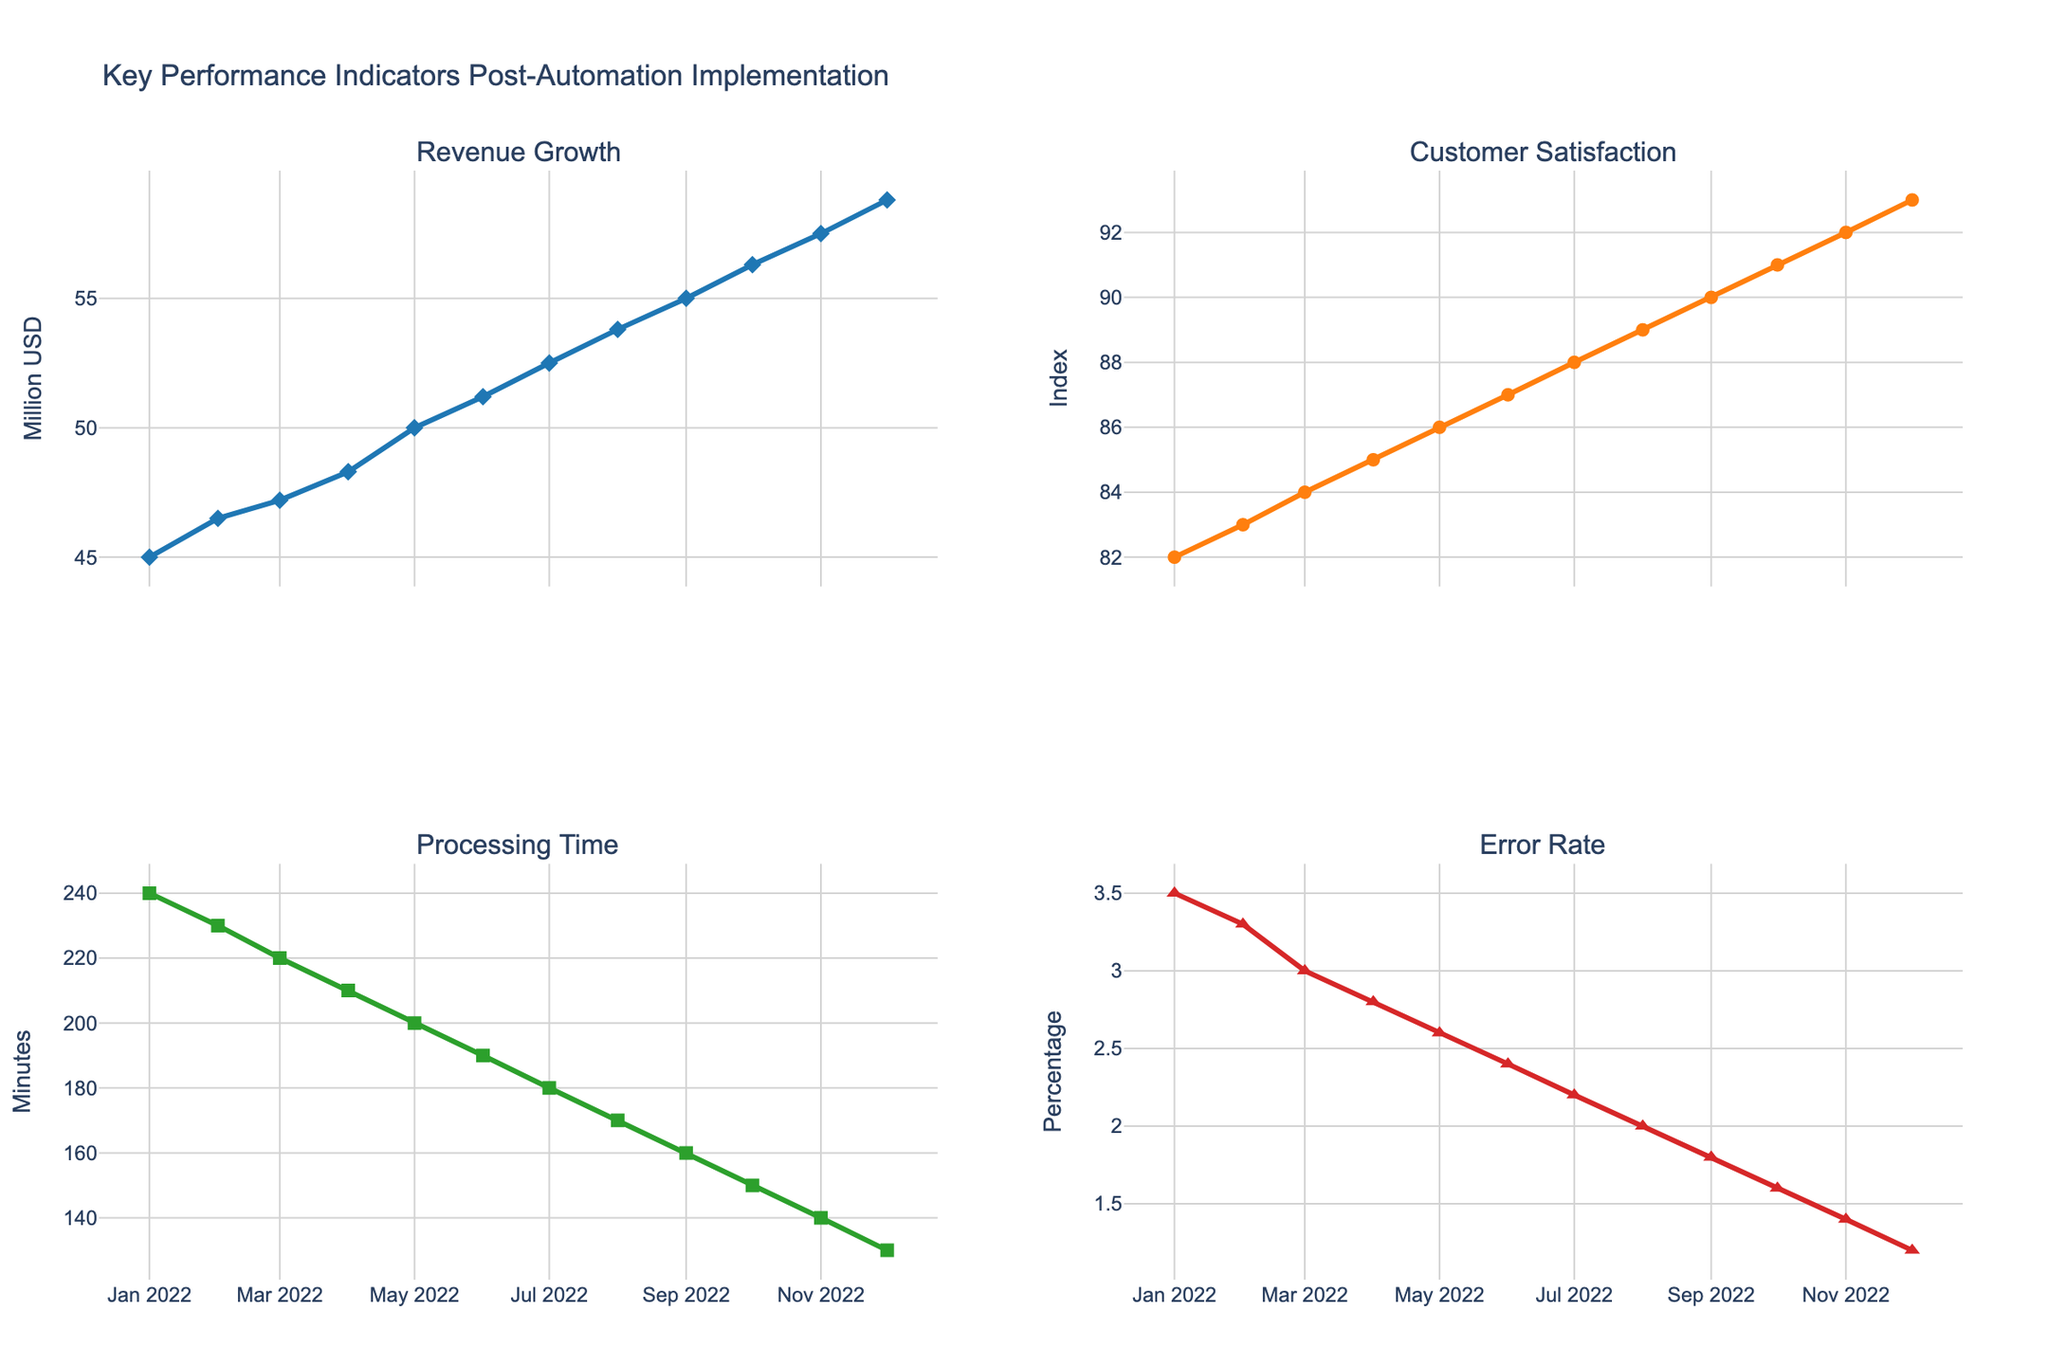1. What is the title of the figure? The title of the figure is prominently displayed at the top.
Answer: Key Performance Indicators Post-Automation Implementation 2. How does the revenue change from January 2022 to December 2022? The revenue is represented by the first subplot. By observing the line, the revenue increases steadily from January to December 2022.
Answer: It increases 3. Which KPI experienced the largest percentage decrease from January to December 2022? To determine the largest percentage decrease, compare the relative changes in Processing Time and Error Rate from January to December. Both metrics are plotted in the second row of the subplots. Processing Time decreases from 240 minutes to 130, which is a reduction of about 45.8%. Error Rate decreases from 3.5% to 1.2%, which is a reduction of about 65.7%.
Answer: Error Rate 4. What is the Customer Satisfaction Index in August 2022? Locate the August 2022 point on the second subplot in the first row. The Customer Satisfaction Index is plotted as a line with markers showing the value.
Answer: 89 5. By how many minutes did the Processing Time decrease from January 2022 to September 2022? Find the Processing Time values for January and September from the data points on the relevant subplot and subtract the latter from the former.
Answer: 80 minutes 6. Compare the Error Rate in February 2022 and November 2022. Which one is higher? Observing the Error Rate subplot, find the points for February and November. February's Error Rate is 3.3%, while it is 1.4% in November.
Answer: February 7. What is the general trend of the Customer Satisfaction Index over the year? By examining the second subplot in the first row, observe the line's trend from left (January) to right (December).
Answer: Increasing 8. What was the revenue in May 2022? Locate the May 2022 point on the revenue subplot, which is the first subplot in the first row, and refer to the y-axis value.
Answer: 50.0 Million USD 9. Is there any month when Customer Satisfaction decreased compared to the previous month? By tracing the Customer Satisfaction Index line plot, check for any points where the index value drops compared to the prior month.
Answer: No 10. If the trend continues, what can be inferred about the Error Rate in the future? Observing the decreasing trend in the Error Rate subplot, it can be inferred that the Error Rate is expected to decrease further if the trend continues.
Answer: It will likely decrease further 